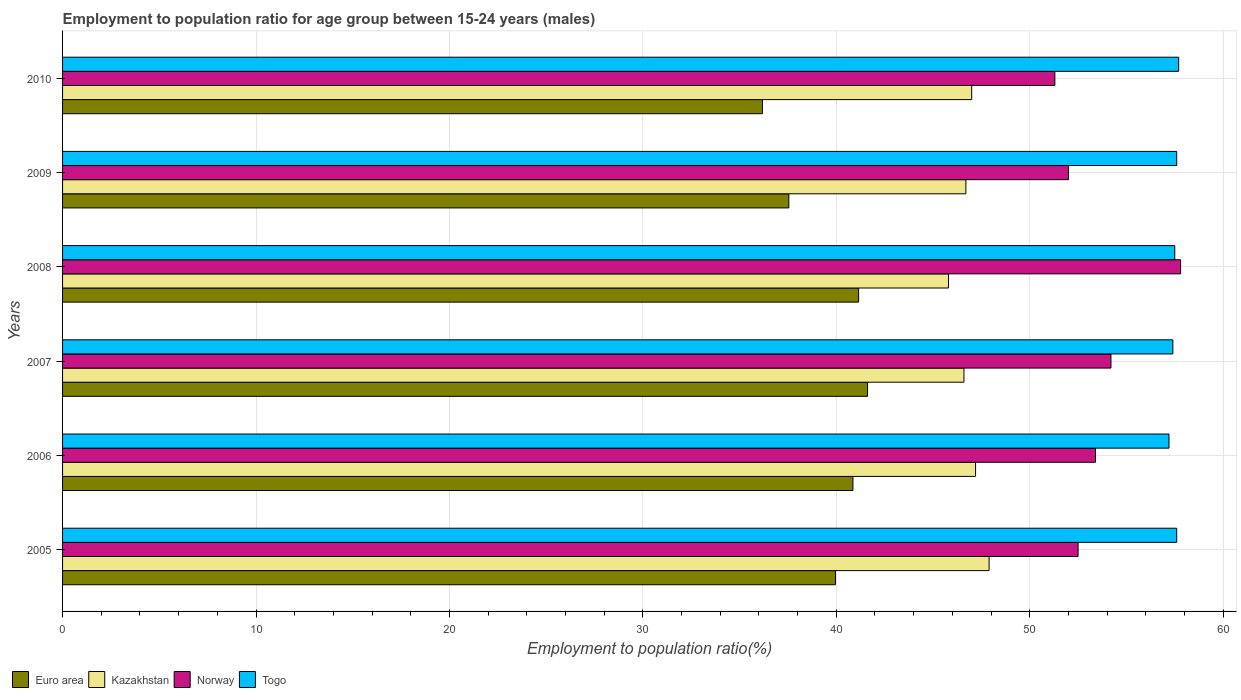Are the number of bars on each tick of the Y-axis equal?
Give a very brief answer. Yes. How many bars are there on the 6th tick from the top?
Keep it short and to the point. 4. How many bars are there on the 5th tick from the bottom?
Give a very brief answer. 4. What is the employment to population ratio in Togo in 2007?
Your response must be concise. 57.4. Across all years, what is the maximum employment to population ratio in Euro area?
Give a very brief answer. 41.62. Across all years, what is the minimum employment to population ratio in Kazakhstan?
Offer a very short reply. 45.8. What is the total employment to population ratio in Norway in the graph?
Your answer should be very brief. 321.2. What is the difference between the employment to population ratio in Norway in 2007 and that in 2010?
Keep it short and to the point. 2.9. What is the difference between the employment to population ratio in Kazakhstan in 2009 and the employment to population ratio in Euro area in 2007?
Provide a succinct answer. 5.08. What is the average employment to population ratio in Togo per year?
Your response must be concise. 57.5. In the year 2007, what is the difference between the employment to population ratio in Euro area and employment to population ratio in Togo?
Offer a terse response. -15.78. In how many years, is the employment to population ratio in Euro area greater than 46 %?
Give a very brief answer. 0. What is the ratio of the employment to population ratio in Kazakhstan in 2008 to that in 2009?
Give a very brief answer. 0.98. Is the difference between the employment to population ratio in Euro area in 2006 and 2008 greater than the difference between the employment to population ratio in Togo in 2006 and 2008?
Keep it short and to the point. Yes. What is the difference between the highest and the second highest employment to population ratio in Euro area?
Your response must be concise. 0.46. What does the 4th bar from the top in 2009 represents?
Provide a short and direct response. Euro area. Is it the case that in every year, the sum of the employment to population ratio in Kazakhstan and employment to population ratio in Norway is greater than the employment to population ratio in Togo?
Offer a very short reply. Yes. Are all the bars in the graph horizontal?
Ensure brevity in your answer.  Yes. How many years are there in the graph?
Offer a very short reply. 6. What is the difference between two consecutive major ticks on the X-axis?
Your response must be concise. 10. Are the values on the major ticks of X-axis written in scientific E-notation?
Keep it short and to the point. No. Does the graph contain any zero values?
Give a very brief answer. No. Does the graph contain grids?
Offer a terse response. Yes. How are the legend labels stacked?
Give a very brief answer. Horizontal. What is the title of the graph?
Your answer should be very brief. Employment to population ratio for age group between 15-24 years (males). What is the label or title of the X-axis?
Your response must be concise. Employment to population ratio(%). What is the label or title of the Y-axis?
Provide a succinct answer. Years. What is the Employment to population ratio(%) in Euro area in 2005?
Your response must be concise. 39.96. What is the Employment to population ratio(%) in Kazakhstan in 2005?
Keep it short and to the point. 47.9. What is the Employment to population ratio(%) in Norway in 2005?
Provide a succinct answer. 52.5. What is the Employment to population ratio(%) of Togo in 2005?
Ensure brevity in your answer.  57.6. What is the Employment to population ratio(%) in Euro area in 2006?
Provide a short and direct response. 40.86. What is the Employment to population ratio(%) in Kazakhstan in 2006?
Offer a terse response. 47.2. What is the Employment to population ratio(%) in Norway in 2006?
Your response must be concise. 53.4. What is the Employment to population ratio(%) of Togo in 2006?
Provide a short and direct response. 57.2. What is the Employment to population ratio(%) of Euro area in 2007?
Provide a short and direct response. 41.62. What is the Employment to population ratio(%) of Kazakhstan in 2007?
Your answer should be compact. 46.6. What is the Employment to population ratio(%) of Norway in 2007?
Give a very brief answer. 54.2. What is the Employment to population ratio(%) of Togo in 2007?
Your answer should be very brief. 57.4. What is the Employment to population ratio(%) of Euro area in 2008?
Give a very brief answer. 41.15. What is the Employment to population ratio(%) in Kazakhstan in 2008?
Provide a short and direct response. 45.8. What is the Employment to population ratio(%) of Norway in 2008?
Offer a very short reply. 57.8. What is the Employment to population ratio(%) of Togo in 2008?
Keep it short and to the point. 57.5. What is the Employment to population ratio(%) in Euro area in 2009?
Your answer should be very brief. 37.55. What is the Employment to population ratio(%) of Kazakhstan in 2009?
Your answer should be compact. 46.7. What is the Employment to population ratio(%) in Norway in 2009?
Your response must be concise. 52. What is the Employment to population ratio(%) in Togo in 2009?
Give a very brief answer. 57.6. What is the Employment to population ratio(%) in Euro area in 2010?
Your response must be concise. 36.18. What is the Employment to population ratio(%) of Norway in 2010?
Your response must be concise. 51.3. What is the Employment to population ratio(%) of Togo in 2010?
Your response must be concise. 57.7. Across all years, what is the maximum Employment to population ratio(%) in Euro area?
Keep it short and to the point. 41.62. Across all years, what is the maximum Employment to population ratio(%) in Kazakhstan?
Keep it short and to the point. 47.9. Across all years, what is the maximum Employment to population ratio(%) in Norway?
Your answer should be very brief. 57.8. Across all years, what is the maximum Employment to population ratio(%) of Togo?
Offer a terse response. 57.7. Across all years, what is the minimum Employment to population ratio(%) in Euro area?
Offer a terse response. 36.18. Across all years, what is the minimum Employment to population ratio(%) in Kazakhstan?
Provide a short and direct response. 45.8. Across all years, what is the minimum Employment to population ratio(%) in Norway?
Keep it short and to the point. 51.3. Across all years, what is the minimum Employment to population ratio(%) of Togo?
Give a very brief answer. 57.2. What is the total Employment to population ratio(%) of Euro area in the graph?
Offer a terse response. 237.32. What is the total Employment to population ratio(%) of Kazakhstan in the graph?
Your answer should be very brief. 281.2. What is the total Employment to population ratio(%) of Norway in the graph?
Make the answer very short. 321.2. What is the total Employment to population ratio(%) of Togo in the graph?
Your answer should be very brief. 345. What is the difference between the Employment to population ratio(%) of Euro area in 2005 and that in 2006?
Your answer should be very brief. -0.9. What is the difference between the Employment to population ratio(%) in Kazakhstan in 2005 and that in 2006?
Give a very brief answer. 0.7. What is the difference between the Employment to population ratio(%) in Euro area in 2005 and that in 2007?
Provide a short and direct response. -1.66. What is the difference between the Employment to population ratio(%) of Kazakhstan in 2005 and that in 2007?
Make the answer very short. 1.3. What is the difference between the Employment to population ratio(%) of Norway in 2005 and that in 2007?
Make the answer very short. -1.7. What is the difference between the Employment to population ratio(%) of Euro area in 2005 and that in 2008?
Your answer should be compact. -1.2. What is the difference between the Employment to population ratio(%) of Norway in 2005 and that in 2008?
Offer a terse response. -5.3. What is the difference between the Employment to population ratio(%) in Togo in 2005 and that in 2008?
Your answer should be compact. 0.1. What is the difference between the Employment to population ratio(%) in Euro area in 2005 and that in 2009?
Offer a very short reply. 2.41. What is the difference between the Employment to population ratio(%) of Euro area in 2005 and that in 2010?
Give a very brief answer. 3.78. What is the difference between the Employment to population ratio(%) in Euro area in 2006 and that in 2007?
Ensure brevity in your answer.  -0.76. What is the difference between the Employment to population ratio(%) in Euro area in 2006 and that in 2008?
Your answer should be compact. -0.29. What is the difference between the Employment to population ratio(%) in Kazakhstan in 2006 and that in 2008?
Make the answer very short. 1.4. What is the difference between the Employment to population ratio(%) in Norway in 2006 and that in 2008?
Your response must be concise. -4.4. What is the difference between the Employment to population ratio(%) in Togo in 2006 and that in 2008?
Provide a short and direct response. -0.3. What is the difference between the Employment to population ratio(%) in Euro area in 2006 and that in 2009?
Provide a short and direct response. 3.31. What is the difference between the Employment to population ratio(%) of Euro area in 2006 and that in 2010?
Your answer should be very brief. 4.68. What is the difference between the Employment to population ratio(%) in Kazakhstan in 2006 and that in 2010?
Your answer should be compact. 0.2. What is the difference between the Employment to population ratio(%) of Togo in 2006 and that in 2010?
Make the answer very short. -0.5. What is the difference between the Employment to population ratio(%) of Euro area in 2007 and that in 2008?
Provide a succinct answer. 0.46. What is the difference between the Employment to population ratio(%) of Euro area in 2007 and that in 2009?
Your answer should be compact. 4.07. What is the difference between the Employment to population ratio(%) of Kazakhstan in 2007 and that in 2009?
Provide a succinct answer. -0.1. What is the difference between the Employment to population ratio(%) in Togo in 2007 and that in 2009?
Your answer should be very brief. -0.2. What is the difference between the Employment to population ratio(%) in Euro area in 2007 and that in 2010?
Your response must be concise. 5.44. What is the difference between the Employment to population ratio(%) of Kazakhstan in 2007 and that in 2010?
Make the answer very short. -0.4. What is the difference between the Employment to population ratio(%) in Euro area in 2008 and that in 2009?
Give a very brief answer. 3.61. What is the difference between the Employment to population ratio(%) in Kazakhstan in 2008 and that in 2009?
Your answer should be compact. -0.9. What is the difference between the Employment to population ratio(%) in Euro area in 2008 and that in 2010?
Offer a terse response. 4.97. What is the difference between the Employment to population ratio(%) in Kazakhstan in 2008 and that in 2010?
Provide a succinct answer. -1.2. What is the difference between the Employment to population ratio(%) of Togo in 2008 and that in 2010?
Provide a succinct answer. -0.2. What is the difference between the Employment to population ratio(%) in Euro area in 2009 and that in 2010?
Make the answer very short. 1.37. What is the difference between the Employment to population ratio(%) in Kazakhstan in 2009 and that in 2010?
Your response must be concise. -0.3. What is the difference between the Employment to population ratio(%) in Norway in 2009 and that in 2010?
Make the answer very short. 0.7. What is the difference between the Employment to population ratio(%) of Euro area in 2005 and the Employment to population ratio(%) of Kazakhstan in 2006?
Keep it short and to the point. -7.24. What is the difference between the Employment to population ratio(%) in Euro area in 2005 and the Employment to population ratio(%) in Norway in 2006?
Make the answer very short. -13.44. What is the difference between the Employment to population ratio(%) in Euro area in 2005 and the Employment to population ratio(%) in Togo in 2006?
Your response must be concise. -17.24. What is the difference between the Employment to population ratio(%) of Kazakhstan in 2005 and the Employment to population ratio(%) of Togo in 2006?
Your answer should be compact. -9.3. What is the difference between the Employment to population ratio(%) in Euro area in 2005 and the Employment to population ratio(%) in Kazakhstan in 2007?
Offer a very short reply. -6.64. What is the difference between the Employment to population ratio(%) of Euro area in 2005 and the Employment to population ratio(%) of Norway in 2007?
Offer a terse response. -14.24. What is the difference between the Employment to population ratio(%) in Euro area in 2005 and the Employment to population ratio(%) in Togo in 2007?
Offer a very short reply. -17.44. What is the difference between the Employment to population ratio(%) of Kazakhstan in 2005 and the Employment to population ratio(%) of Togo in 2007?
Make the answer very short. -9.5. What is the difference between the Employment to population ratio(%) in Euro area in 2005 and the Employment to population ratio(%) in Kazakhstan in 2008?
Ensure brevity in your answer.  -5.84. What is the difference between the Employment to population ratio(%) in Euro area in 2005 and the Employment to population ratio(%) in Norway in 2008?
Keep it short and to the point. -17.84. What is the difference between the Employment to population ratio(%) of Euro area in 2005 and the Employment to population ratio(%) of Togo in 2008?
Your answer should be compact. -17.54. What is the difference between the Employment to population ratio(%) in Kazakhstan in 2005 and the Employment to population ratio(%) in Norway in 2008?
Provide a short and direct response. -9.9. What is the difference between the Employment to population ratio(%) in Norway in 2005 and the Employment to population ratio(%) in Togo in 2008?
Offer a very short reply. -5. What is the difference between the Employment to population ratio(%) in Euro area in 2005 and the Employment to population ratio(%) in Kazakhstan in 2009?
Offer a terse response. -6.74. What is the difference between the Employment to population ratio(%) in Euro area in 2005 and the Employment to population ratio(%) in Norway in 2009?
Provide a succinct answer. -12.04. What is the difference between the Employment to population ratio(%) in Euro area in 2005 and the Employment to population ratio(%) in Togo in 2009?
Your answer should be very brief. -17.64. What is the difference between the Employment to population ratio(%) of Kazakhstan in 2005 and the Employment to population ratio(%) of Norway in 2009?
Ensure brevity in your answer.  -4.1. What is the difference between the Employment to population ratio(%) of Norway in 2005 and the Employment to population ratio(%) of Togo in 2009?
Your answer should be compact. -5.1. What is the difference between the Employment to population ratio(%) of Euro area in 2005 and the Employment to population ratio(%) of Kazakhstan in 2010?
Your answer should be very brief. -7.04. What is the difference between the Employment to population ratio(%) in Euro area in 2005 and the Employment to population ratio(%) in Norway in 2010?
Provide a succinct answer. -11.34. What is the difference between the Employment to population ratio(%) in Euro area in 2005 and the Employment to population ratio(%) in Togo in 2010?
Keep it short and to the point. -17.74. What is the difference between the Employment to population ratio(%) of Kazakhstan in 2005 and the Employment to population ratio(%) of Norway in 2010?
Give a very brief answer. -3.4. What is the difference between the Employment to population ratio(%) of Norway in 2005 and the Employment to population ratio(%) of Togo in 2010?
Provide a short and direct response. -5.2. What is the difference between the Employment to population ratio(%) of Euro area in 2006 and the Employment to population ratio(%) of Kazakhstan in 2007?
Ensure brevity in your answer.  -5.74. What is the difference between the Employment to population ratio(%) in Euro area in 2006 and the Employment to population ratio(%) in Norway in 2007?
Keep it short and to the point. -13.34. What is the difference between the Employment to population ratio(%) in Euro area in 2006 and the Employment to population ratio(%) in Togo in 2007?
Keep it short and to the point. -16.54. What is the difference between the Employment to population ratio(%) in Kazakhstan in 2006 and the Employment to population ratio(%) in Norway in 2007?
Offer a terse response. -7. What is the difference between the Employment to population ratio(%) of Kazakhstan in 2006 and the Employment to population ratio(%) of Togo in 2007?
Offer a very short reply. -10.2. What is the difference between the Employment to population ratio(%) in Norway in 2006 and the Employment to population ratio(%) in Togo in 2007?
Provide a succinct answer. -4. What is the difference between the Employment to population ratio(%) in Euro area in 2006 and the Employment to population ratio(%) in Kazakhstan in 2008?
Your answer should be very brief. -4.94. What is the difference between the Employment to population ratio(%) of Euro area in 2006 and the Employment to population ratio(%) of Norway in 2008?
Give a very brief answer. -16.94. What is the difference between the Employment to population ratio(%) in Euro area in 2006 and the Employment to population ratio(%) in Togo in 2008?
Offer a very short reply. -16.64. What is the difference between the Employment to population ratio(%) of Kazakhstan in 2006 and the Employment to population ratio(%) of Togo in 2008?
Your answer should be very brief. -10.3. What is the difference between the Employment to population ratio(%) in Norway in 2006 and the Employment to population ratio(%) in Togo in 2008?
Provide a succinct answer. -4.1. What is the difference between the Employment to population ratio(%) of Euro area in 2006 and the Employment to population ratio(%) of Kazakhstan in 2009?
Make the answer very short. -5.84. What is the difference between the Employment to population ratio(%) of Euro area in 2006 and the Employment to population ratio(%) of Norway in 2009?
Ensure brevity in your answer.  -11.14. What is the difference between the Employment to population ratio(%) of Euro area in 2006 and the Employment to population ratio(%) of Togo in 2009?
Give a very brief answer. -16.74. What is the difference between the Employment to population ratio(%) in Kazakhstan in 2006 and the Employment to population ratio(%) in Togo in 2009?
Give a very brief answer. -10.4. What is the difference between the Employment to population ratio(%) in Euro area in 2006 and the Employment to population ratio(%) in Kazakhstan in 2010?
Give a very brief answer. -6.14. What is the difference between the Employment to population ratio(%) of Euro area in 2006 and the Employment to population ratio(%) of Norway in 2010?
Your response must be concise. -10.44. What is the difference between the Employment to population ratio(%) in Euro area in 2006 and the Employment to population ratio(%) in Togo in 2010?
Make the answer very short. -16.84. What is the difference between the Employment to population ratio(%) of Kazakhstan in 2006 and the Employment to population ratio(%) of Norway in 2010?
Make the answer very short. -4.1. What is the difference between the Employment to population ratio(%) of Kazakhstan in 2006 and the Employment to population ratio(%) of Togo in 2010?
Make the answer very short. -10.5. What is the difference between the Employment to population ratio(%) of Euro area in 2007 and the Employment to population ratio(%) of Kazakhstan in 2008?
Your response must be concise. -4.18. What is the difference between the Employment to population ratio(%) in Euro area in 2007 and the Employment to population ratio(%) in Norway in 2008?
Keep it short and to the point. -16.18. What is the difference between the Employment to population ratio(%) of Euro area in 2007 and the Employment to population ratio(%) of Togo in 2008?
Keep it short and to the point. -15.88. What is the difference between the Employment to population ratio(%) in Kazakhstan in 2007 and the Employment to population ratio(%) in Togo in 2008?
Your answer should be very brief. -10.9. What is the difference between the Employment to population ratio(%) in Euro area in 2007 and the Employment to population ratio(%) in Kazakhstan in 2009?
Offer a very short reply. -5.08. What is the difference between the Employment to population ratio(%) of Euro area in 2007 and the Employment to population ratio(%) of Norway in 2009?
Provide a succinct answer. -10.38. What is the difference between the Employment to population ratio(%) in Euro area in 2007 and the Employment to population ratio(%) in Togo in 2009?
Make the answer very short. -15.98. What is the difference between the Employment to population ratio(%) in Euro area in 2007 and the Employment to population ratio(%) in Kazakhstan in 2010?
Ensure brevity in your answer.  -5.38. What is the difference between the Employment to population ratio(%) of Euro area in 2007 and the Employment to population ratio(%) of Norway in 2010?
Your answer should be very brief. -9.68. What is the difference between the Employment to population ratio(%) in Euro area in 2007 and the Employment to population ratio(%) in Togo in 2010?
Your answer should be very brief. -16.08. What is the difference between the Employment to population ratio(%) of Kazakhstan in 2007 and the Employment to population ratio(%) of Togo in 2010?
Offer a very short reply. -11.1. What is the difference between the Employment to population ratio(%) of Euro area in 2008 and the Employment to population ratio(%) of Kazakhstan in 2009?
Keep it short and to the point. -5.55. What is the difference between the Employment to population ratio(%) in Euro area in 2008 and the Employment to population ratio(%) in Norway in 2009?
Make the answer very short. -10.85. What is the difference between the Employment to population ratio(%) of Euro area in 2008 and the Employment to population ratio(%) of Togo in 2009?
Ensure brevity in your answer.  -16.45. What is the difference between the Employment to population ratio(%) in Kazakhstan in 2008 and the Employment to population ratio(%) in Togo in 2009?
Keep it short and to the point. -11.8. What is the difference between the Employment to population ratio(%) of Norway in 2008 and the Employment to population ratio(%) of Togo in 2009?
Your answer should be very brief. 0.2. What is the difference between the Employment to population ratio(%) of Euro area in 2008 and the Employment to population ratio(%) of Kazakhstan in 2010?
Keep it short and to the point. -5.85. What is the difference between the Employment to population ratio(%) in Euro area in 2008 and the Employment to population ratio(%) in Norway in 2010?
Ensure brevity in your answer.  -10.15. What is the difference between the Employment to population ratio(%) of Euro area in 2008 and the Employment to population ratio(%) of Togo in 2010?
Provide a succinct answer. -16.55. What is the difference between the Employment to population ratio(%) of Kazakhstan in 2008 and the Employment to population ratio(%) of Norway in 2010?
Offer a terse response. -5.5. What is the difference between the Employment to population ratio(%) in Kazakhstan in 2008 and the Employment to population ratio(%) in Togo in 2010?
Give a very brief answer. -11.9. What is the difference between the Employment to population ratio(%) in Euro area in 2009 and the Employment to population ratio(%) in Kazakhstan in 2010?
Your answer should be very brief. -9.45. What is the difference between the Employment to population ratio(%) of Euro area in 2009 and the Employment to population ratio(%) of Norway in 2010?
Offer a very short reply. -13.75. What is the difference between the Employment to population ratio(%) of Euro area in 2009 and the Employment to population ratio(%) of Togo in 2010?
Make the answer very short. -20.15. What is the difference between the Employment to population ratio(%) of Kazakhstan in 2009 and the Employment to population ratio(%) of Togo in 2010?
Your response must be concise. -11. What is the difference between the Employment to population ratio(%) of Norway in 2009 and the Employment to population ratio(%) of Togo in 2010?
Keep it short and to the point. -5.7. What is the average Employment to population ratio(%) in Euro area per year?
Provide a short and direct response. 39.55. What is the average Employment to population ratio(%) in Kazakhstan per year?
Your answer should be compact. 46.87. What is the average Employment to population ratio(%) of Norway per year?
Offer a very short reply. 53.53. What is the average Employment to population ratio(%) of Togo per year?
Provide a short and direct response. 57.5. In the year 2005, what is the difference between the Employment to population ratio(%) in Euro area and Employment to population ratio(%) in Kazakhstan?
Give a very brief answer. -7.94. In the year 2005, what is the difference between the Employment to population ratio(%) of Euro area and Employment to population ratio(%) of Norway?
Provide a succinct answer. -12.54. In the year 2005, what is the difference between the Employment to population ratio(%) in Euro area and Employment to population ratio(%) in Togo?
Provide a succinct answer. -17.64. In the year 2005, what is the difference between the Employment to population ratio(%) of Kazakhstan and Employment to population ratio(%) of Togo?
Offer a very short reply. -9.7. In the year 2006, what is the difference between the Employment to population ratio(%) of Euro area and Employment to population ratio(%) of Kazakhstan?
Your answer should be compact. -6.34. In the year 2006, what is the difference between the Employment to population ratio(%) in Euro area and Employment to population ratio(%) in Norway?
Ensure brevity in your answer.  -12.54. In the year 2006, what is the difference between the Employment to population ratio(%) of Euro area and Employment to population ratio(%) of Togo?
Offer a very short reply. -16.34. In the year 2006, what is the difference between the Employment to population ratio(%) in Kazakhstan and Employment to population ratio(%) in Togo?
Give a very brief answer. -10. In the year 2007, what is the difference between the Employment to population ratio(%) of Euro area and Employment to population ratio(%) of Kazakhstan?
Provide a succinct answer. -4.98. In the year 2007, what is the difference between the Employment to population ratio(%) of Euro area and Employment to population ratio(%) of Norway?
Give a very brief answer. -12.58. In the year 2007, what is the difference between the Employment to population ratio(%) in Euro area and Employment to population ratio(%) in Togo?
Keep it short and to the point. -15.78. In the year 2008, what is the difference between the Employment to population ratio(%) of Euro area and Employment to population ratio(%) of Kazakhstan?
Provide a short and direct response. -4.65. In the year 2008, what is the difference between the Employment to population ratio(%) of Euro area and Employment to population ratio(%) of Norway?
Provide a succinct answer. -16.65. In the year 2008, what is the difference between the Employment to population ratio(%) of Euro area and Employment to population ratio(%) of Togo?
Offer a very short reply. -16.35. In the year 2009, what is the difference between the Employment to population ratio(%) in Euro area and Employment to population ratio(%) in Kazakhstan?
Ensure brevity in your answer.  -9.15. In the year 2009, what is the difference between the Employment to population ratio(%) of Euro area and Employment to population ratio(%) of Norway?
Keep it short and to the point. -14.45. In the year 2009, what is the difference between the Employment to population ratio(%) of Euro area and Employment to population ratio(%) of Togo?
Ensure brevity in your answer.  -20.05. In the year 2009, what is the difference between the Employment to population ratio(%) of Kazakhstan and Employment to population ratio(%) of Norway?
Ensure brevity in your answer.  -5.3. In the year 2010, what is the difference between the Employment to population ratio(%) of Euro area and Employment to population ratio(%) of Kazakhstan?
Provide a short and direct response. -10.82. In the year 2010, what is the difference between the Employment to population ratio(%) in Euro area and Employment to population ratio(%) in Norway?
Provide a short and direct response. -15.12. In the year 2010, what is the difference between the Employment to population ratio(%) in Euro area and Employment to population ratio(%) in Togo?
Your answer should be very brief. -21.52. In the year 2010, what is the difference between the Employment to population ratio(%) of Kazakhstan and Employment to population ratio(%) of Norway?
Offer a very short reply. -4.3. In the year 2010, what is the difference between the Employment to population ratio(%) of Norway and Employment to population ratio(%) of Togo?
Your response must be concise. -6.4. What is the ratio of the Employment to population ratio(%) of Euro area in 2005 to that in 2006?
Provide a short and direct response. 0.98. What is the ratio of the Employment to population ratio(%) of Kazakhstan in 2005 to that in 2006?
Provide a short and direct response. 1.01. What is the ratio of the Employment to population ratio(%) of Norway in 2005 to that in 2006?
Give a very brief answer. 0.98. What is the ratio of the Employment to population ratio(%) in Togo in 2005 to that in 2006?
Provide a succinct answer. 1.01. What is the ratio of the Employment to population ratio(%) of Euro area in 2005 to that in 2007?
Ensure brevity in your answer.  0.96. What is the ratio of the Employment to population ratio(%) in Kazakhstan in 2005 to that in 2007?
Your answer should be compact. 1.03. What is the ratio of the Employment to population ratio(%) in Norway in 2005 to that in 2007?
Ensure brevity in your answer.  0.97. What is the ratio of the Employment to population ratio(%) in Togo in 2005 to that in 2007?
Give a very brief answer. 1. What is the ratio of the Employment to population ratio(%) in Euro area in 2005 to that in 2008?
Your response must be concise. 0.97. What is the ratio of the Employment to population ratio(%) in Kazakhstan in 2005 to that in 2008?
Give a very brief answer. 1.05. What is the ratio of the Employment to population ratio(%) of Norway in 2005 to that in 2008?
Offer a very short reply. 0.91. What is the ratio of the Employment to population ratio(%) of Togo in 2005 to that in 2008?
Offer a very short reply. 1. What is the ratio of the Employment to population ratio(%) in Euro area in 2005 to that in 2009?
Give a very brief answer. 1.06. What is the ratio of the Employment to population ratio(%) of Kazakhstan in 2005 to that in 2009?
Your answer should be very brief. 1.03. What is the ratio of the Employment to population ratio(%) of Norway in 2005 to that in 2009?
Ensure brevity in your answer.  1.01. What is the ratio of the Employment to population ratio(%) in Togo in 2005 to that in 2009?
Offer a very short reply. 1. What is the ratio of the Employment to population ratio(%) of Euro area in 2005 to that in 2010?
Keep it short and to the point. 1.1. What is the ratio of the Employment to population ratio(%) of Kazakhstan in 2005 to that in 2010?
Provide a succinct answer. 1.02. What is the ratio of the Employment to population ratio(%) of Norway in 2005 to that in 2010?
Provide a succinct answer. 1.02. What is the ratio of the Employment to population ratio(%) of Togo in 2005 to that in 2010?
Provide a succinct answer. 1. What is the ratio of the Employment to population ratio(%) of Euro area in 2006 to that in 2007?
Make the answer very short. 0.98. What is the ratio of the Employment to population ratio(%) of Kazakhstan in 2006 to that in 2007?
Your answer should be very brief. 1.01. What is the ratio of the Employment to population ratio(%) in Norway in 2006 to that in 2007?
Provide a short and direct response. 0.99. What is the ratio of the Employment to population ratio(%) in Togo in 2006 to that in 2007?
Your response must be concise. 1. What is the ratio of the Employment to population ratio(%) of Kazakhstan in 2006 to that in 2008?
Ensure brevity in your answer.  1.03. What is the ratio of the Employment to population ratio(%) in Norway in 2006 to that in 2008?
Give a very brief answer. 0.92. What is the ratio of the Employment to population ratio(%) in Euro area in 2006 to that in 2009?
Provide a short and direct response. 1.09. What is the ratio of the Employment to population ratio(%) of Kazakhstan in 2006 to that in 2009?
Your response must be concise. 1.01. What is the ratio of the Employment to population ratio(%) in Norway in 2006 to that in 2009?
Give a very brief answer. 1.03. What is the ratio of the Employment to population ratio(%) of Togo in 2006 to that in 2009?
Offer a very short reply. 0.99. What is the ratio of the Employment to population ratio(%) of Euro area in 2006 to that in 2010?
Provide a short and direct response. 1.13. What is the ratio of the Employment to population ratio(%) of Kazakhstan in 2006 to that in 2010?
Your response must be concise. 1. What is the ratio of the Employment to population ratio(%) of Norway in 2006 to that in 2010?
Your answer should be very brief. 1.04. What is the ratio of the Employment to population ratio(%) of Euro area in 2007 to that in 2008?
Ensure brevity in your answer.  1.01. What is the ratio of the Employment to population ratio(%) in Kazakhstan in 2007 to that in 2008?
Offer a terse response. 1.02. What is the ratio of the Employment to population ratio(%) in Norway in 2007 to that in 2008?
Ensure brevity in your answer.  0.94. What is the ratio of the Employment to population ratio(%) in Euro area in 2007 to that in 2009?
Your response must be concise. 1.11. What is the ratio of the Employment to population ratio(%) of Norway in 2007 to that in 2009?
Your response must be concise. 1.04. What is the ratio of the Employment to population ratio(%) of Togo in 2007 to that in 2009?
Offer a very short reply. 1. What is the ratio of the Employment to population ratio(%) in Euro area in 2007 to that in 2010?
Provide a short and direct response. 1.15. What is the ratio of the Employment to population ratio(%) of Norway in 2007 to that in 2010?
Provide a succinct answer. 1.06. What is the ratio of the Employment to population ratio(%) of Euro area in 2008 to that in 2009?
Provide a short and direct response. 1.1. What is the ratio of the Employment to population ratio(%) of Kazakhstan in 2008 to that in 2009?
Ensure brevity in your answer.  0.98. What is the ratio of the Employment to population ratio(%) in Norway in 2008 to that in 2009?
Ensure brevity in your answer.  1.11. What is the ratio of the Employment to population ratio(%) in Togo in 2008 to that in 2009?
Offer a very short reply. 1. What is the ratio of the Employment to population ratio(%) in Euro area in 2008 to that in 2010?
Your answer should be very brief. 1.14. What is the ratio of the Employment to population ratio(%) in Kazakhstan in 2008 to that in 2010?
Offer a terse response. 0.97. What is the ratio of the Employment to population ratio(%) of Norway in 2008 to that in 2010?
Provide a short and direct response. 1.13. What is the ratio of the Employment to population ratio(%) of Togo in 2008 to that in 2010?
Ensure brevity in your answer.  1. What is the ratio of the Employment to population ratio(%) of Euro area in 2009 to that in 2010?
Give a very brief answer. 1.04. What is the ratio of the Employment to population ratio(%) in Kazakhstan in 2009 to that in 2010?
Offer a terse response. 0.99. What is the ratio of the Employment to population ratio(%) of Norway in 2009 to that in 2010?
Give a very brief answer. 1.01. What is the ratio of the Employment to population ratio(%) of Togo in 2009 to that in 2010?
Offer a terse response. 1. What is the difference between the highest and the second highest Employment to population ratio(%) of Euro area?
Make the answer very short. 0.46. What is the difference between the highest and the second highest Employment to population ratio(%) in Norway?
Provide a succinct answer. 3.6. What is the difference between the highest and the second highest Employment to population ratio(%) of Togo?
Your answer should be very brief. 0.1. What is the difference between the highest and the lowest Employment to population ratio(%) of Euro area?
Ensure brevity in your answer.  5.44. What is the difference between the highest and the lowest Employment to population ratio(%) of Norway?
Your answer should be compact. 6.5. What is the difference between the highest and the lowest Employment to population ratio(%) in Togo?
Your response must be concise. 0.5. 